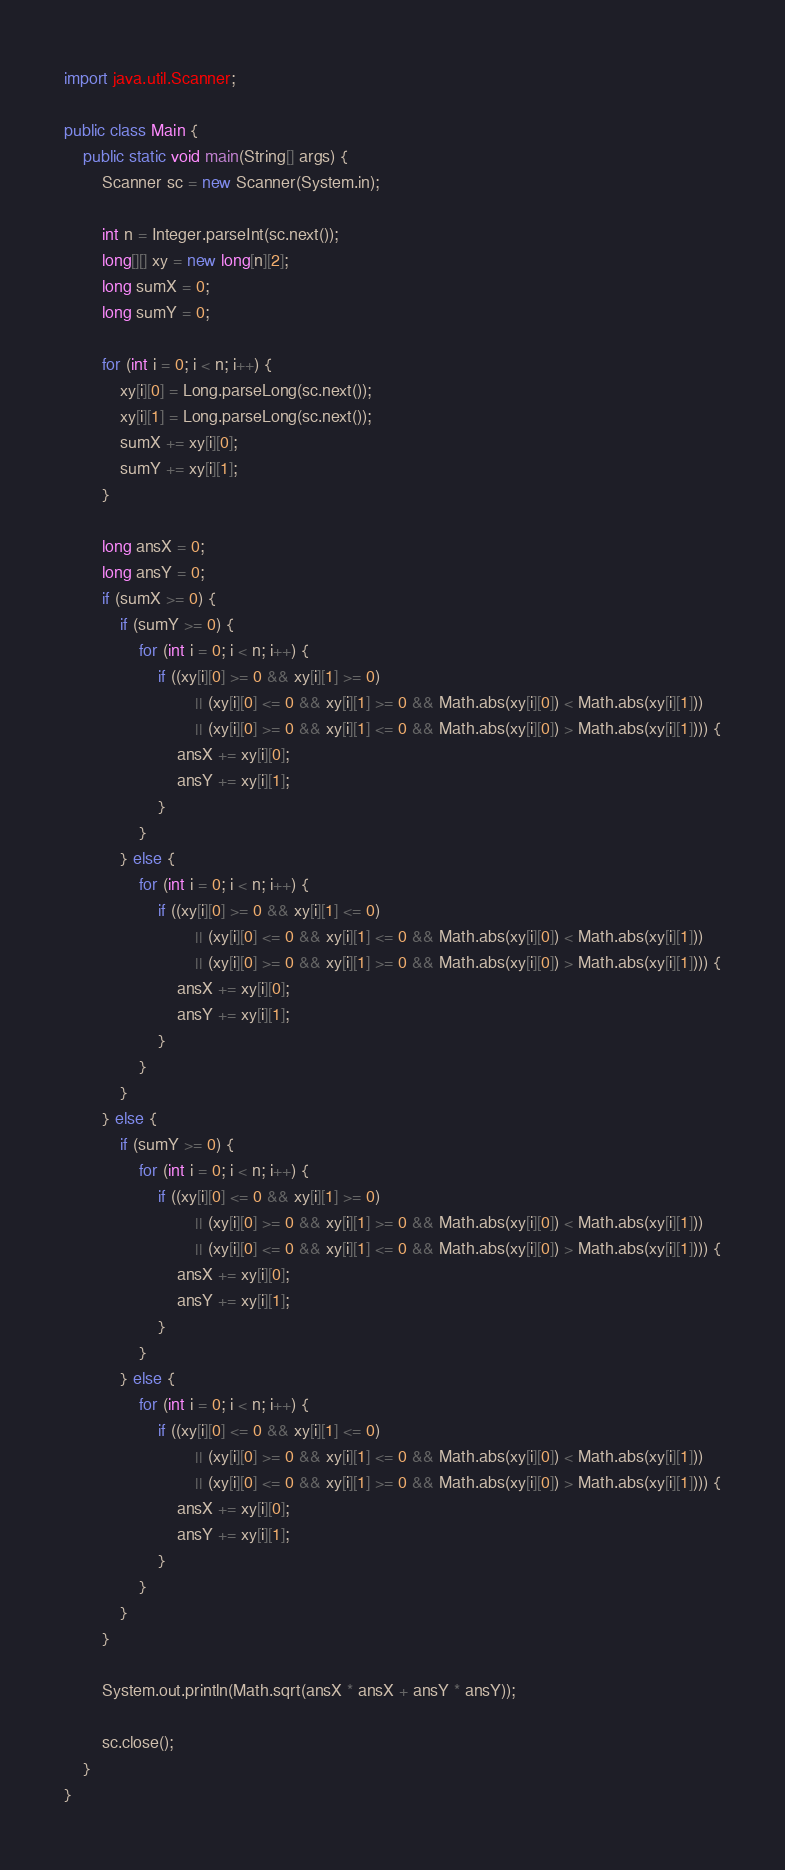<code> <loc_0><loc_0><loc_500><loc_500><_Java_>import java.util.Scanner;

public class Main {
	public static void main(String[] args) {
		Scanner sc = new Scanner(System.in);

		int n = Integer.parseInt(sc.next());
		long[][] xy = new long[n][2];
		long sumX = 0;
		long sumY = 0;

		for (int i = 0; i < n; i++) {
			xy[i][0] = Long.parseLong(sc.next());
			xy[i][1] = Long.parseLong(sc.next());
			sumX += xy[i][0];
			sumY += xy[i][1];
		}

		long ansX = 0;
		long ansY = 0;
		if (sumX >= 0) {
			if (sumY >= 0) {
				for (int i = 0; i < n; i++) {
					if ((xy[i][0] >= 0 && xy[i][1] >= 0)
							|| (xy[i][0] <= 0 && xy[i][1] >= 0 && Math.abs(xy[i][0]) < Math.abs(xy[i][1]))
							|| (xy[i][0] >= 0 && xy[i][1] <= 0 && Math.abs(xy[i][0]) > Math.abs(xy[i][1]))) {
						ansX += xy[i][0];
						ansY += xy[i][1];
					}
				}
			} else {
				for (int i = 0; i < n; i++) {
					if ((xy[i][0] >= 0 && xy[i][1] <= 0)
							|| (xy[i][0] <= 0 && xy[i][1] <= 0 && Math.abs(xy[i][0]) < Math.abs(xy[i][1]))
							|| (xy[i][0] >= 0 && xy[i][1] >= 0 && Math.abs(xy[i][0]) > Math.abs(xy[i][1]))) {
						ansX += xy[i][0];
						ansY += xy[i][1];
					}
				}
			}
		} else {
			if (sumY >= 0) {
				for (int i = 0; i < n; i++) {
					if ((xy[i][0] <= 0 && xy[i][1] >= 0)
							|| (xy[i][0] >= 0 && xy[i][1] >= 0 && Math.abs(xy[i][0]) < Math.abs(xy[i][1]))
							|| (xy[i][0] <= 0 && xy[i][1] <= 0 && Math.abs(xy[i][0]) > Math.abs(xy[i][1]))) {
						ansX += xy[i][0];
						ansY += xy[i][1];
					}
				}
			} else {
				for (int i = 0; i < n; i++) {
					if ((xy[i][0] <= 0 && xy[i][1] <= 0)
							|| (xy[i][0] >= 0 && xy[i][1] <= 0 && Math.abs(xy[i][0]) < Math.abs(xy[i][1]))
							|| (xy[i][0] <= 0 && xy[i][1] >= 0 && Math.abs(xy[i][0]) > Math.abs(xy[i][1]))) {
						ansX += xy[i][0];
						ansY += xy[i][1];
					}
				}
			}
		}

		System.out.println(Math.sqrt(ansX * ansX + ansY * ansY));

		sc.close();
	}
}</code> 